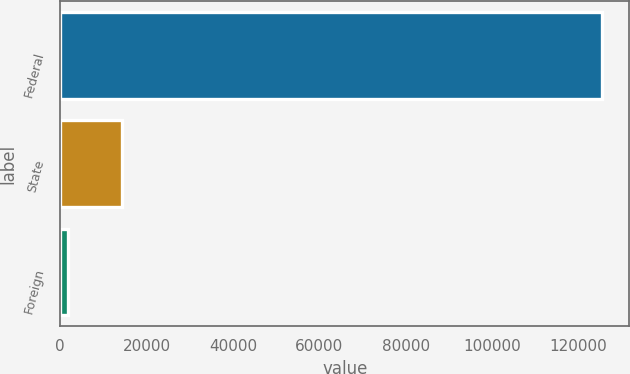Convert chart to OTSL. <chart><loc_0><loc_0><loc_500><loc_500><bar_chart><fcel>Federal<fcel>State<fcel>Foreign<nl><fcel>125557<fcel>14243.2<fcel>1875<nl></chart> 